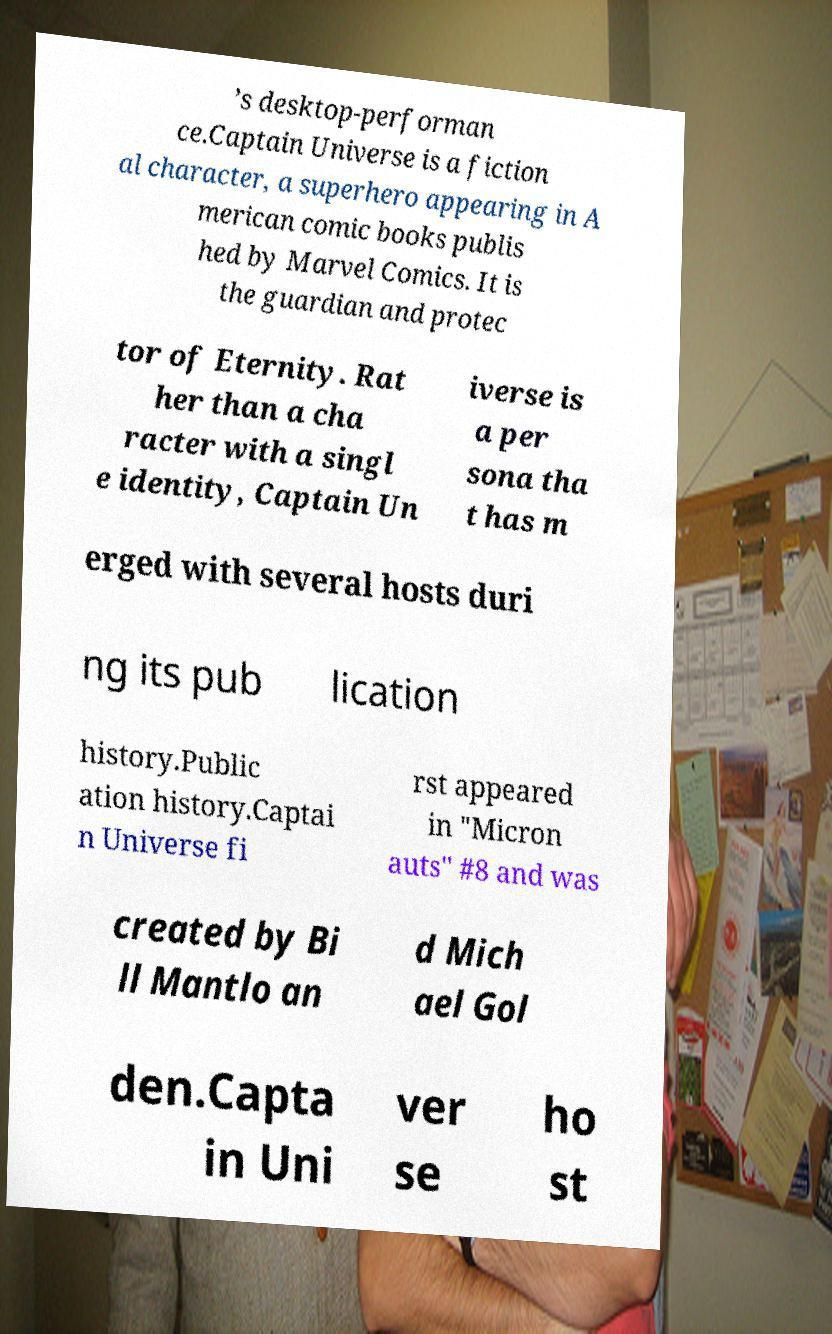I need the written content from this picture converted into text. Can you do that? ’s desktop-performan ce.Captain Universe is a fiction al character, a superhero appearing in A merican comic books publis hed by Marvel Comics. It is the guardian and protec tor of Eternity. Rat her than a cha racter with a singl e identity, Captain Un iverse is a per sona tha t has m erged with several hosts duri ng its pub lication history.Public ation history.Captai n Universe fi rst appeared in "Micron auts" #8 and was created by Bi ll Mantlo an d Mich ael Gol den.Capta in Uni ver se ho st 